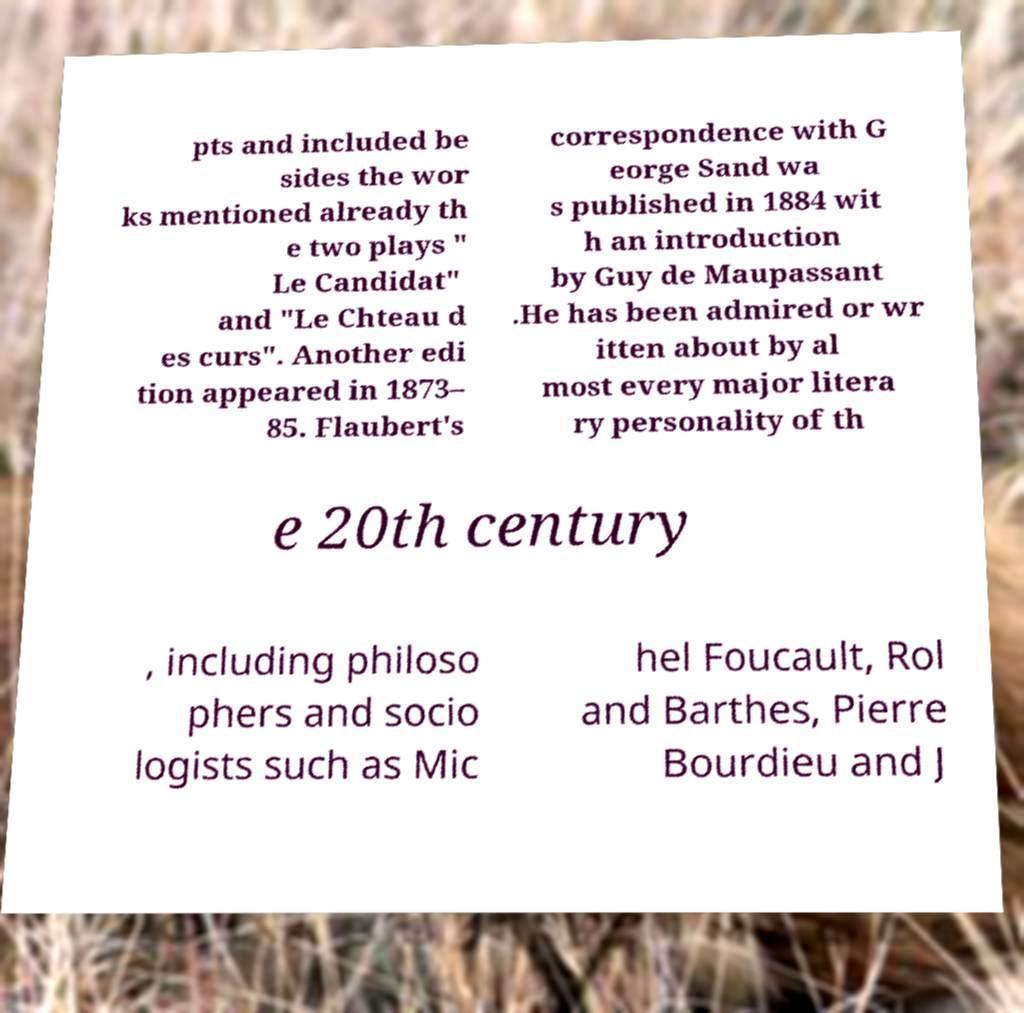Please read and relay the text visible in this image. What does it say? pts and included be sides the wor ks mentioned already th e two plays " Le Candidat" and "Le Chteau d es curs". Another edi tion appeared in 1873– 85. Flaubert's correspondence with G eorge Sand wa s published in 1884 wit h an introduction by Guy de Maupassant .He has been admired or wr itten about by al most every major litera ry personality of th e 20th century , including philoso phers and socio logists such as Mic hel Foucault, Rol and Barthes, Pierre Bourdieu and J 